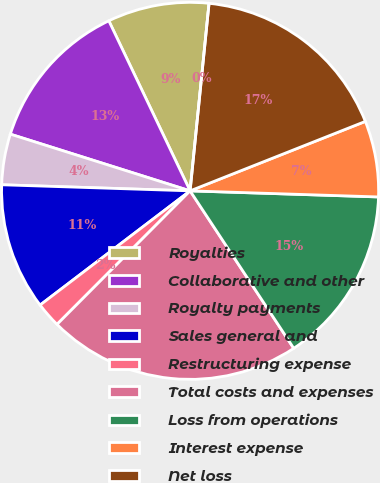Convert chart. <chart><loc_0><loc_0><loc_500><loc_500><pie_chart><fcel>Royalties<fcel>Collaborative and other<fcel>Royalty payments<fcel>Sales general and<fcel>Restructuring expense<fcel>Total costs and expenses<fcel>Loss from operations<fcel>Interest expense<fcel>Net loss<fcel>Basic and diluted net loss per<nl><fcel>8.7%<fcel>13.04%<fcel>4.35%<fcel>10.87%<fcel>2.17%<fcel>21.74%<fcel>15.22%<fcel>6.52%<fcel>17.39%<fcel>0.0%<nl></chart> 